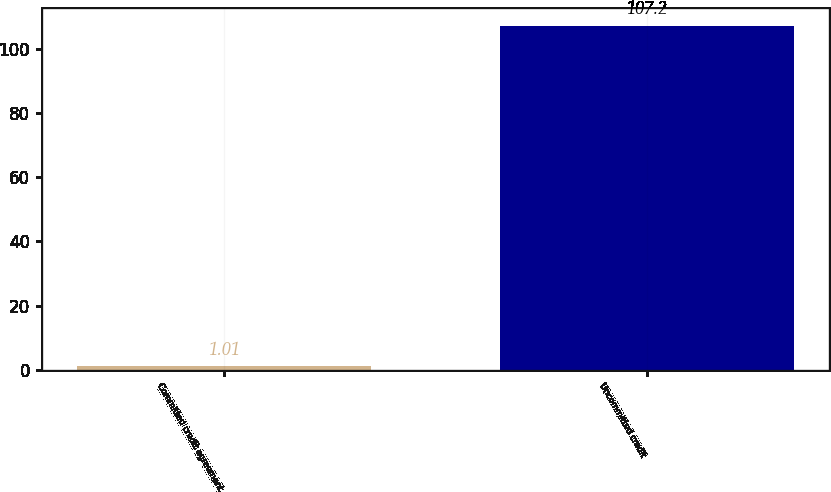Convert chart. <chart><loc_0><loc_0><loc_500><loc_500><bar_chart><fcel>Committed credit agreement<fcel>Uncommitted credit<nl><fcel>1.01<fcel>107.2<nl></chart> 